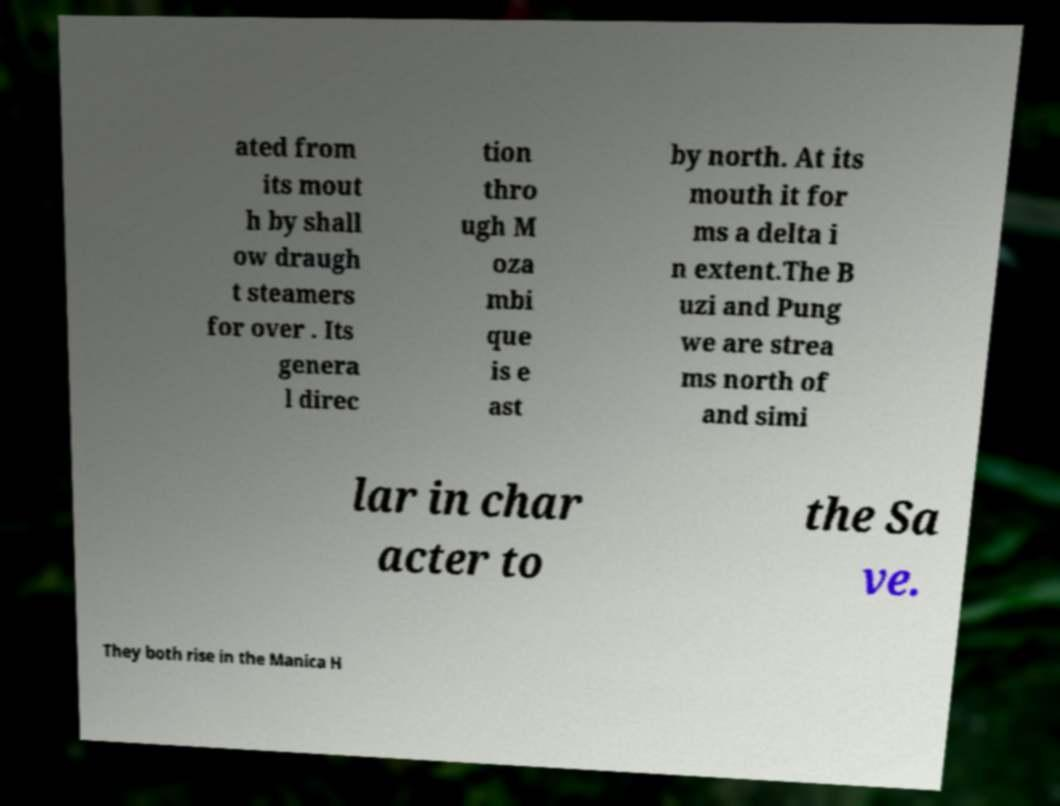What messages or text are displayed in this image? I need them in a readable, typed format. ated from its mout h by shall ow draugh t steamers for over . Its genera l direc tion thro ugh M oza mbi que is e ast by north. At its mouth it for ms a delta i n extent.The B uzi and Pung we are strea ms north of and simi lar in char acter to the Sa ve. They both rise in the Manica H 